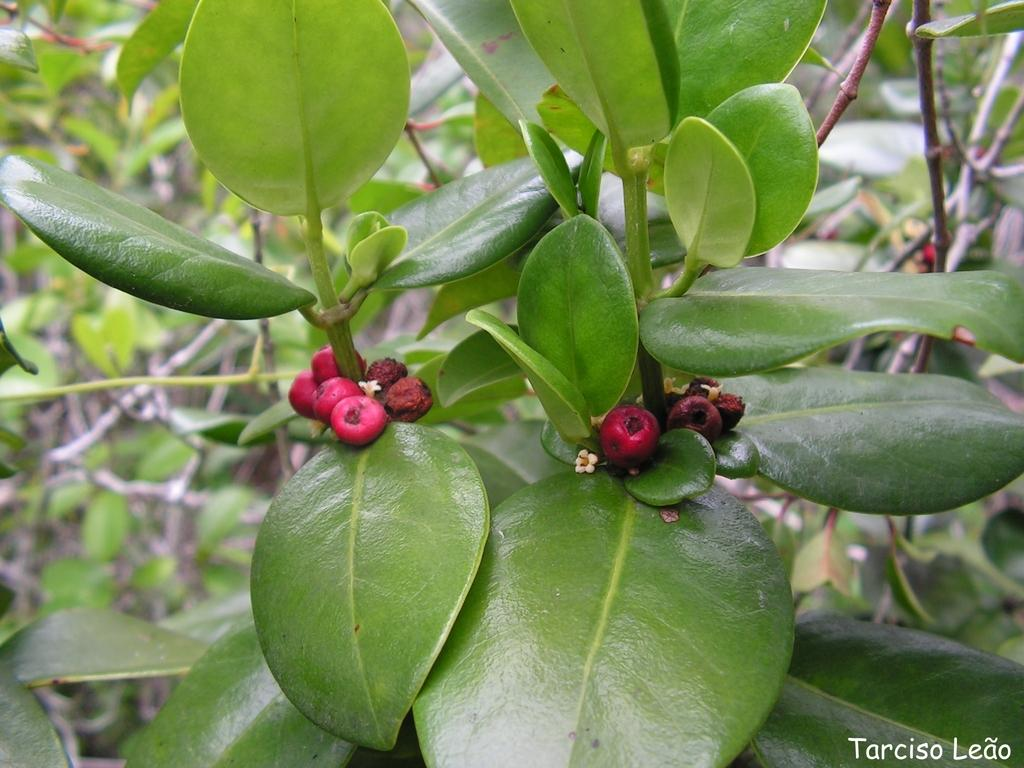What type of vegetation is present in the image? There are trees with fruits in the image. Can you describe any text visible in the image? There is text at the bottom right corner of the image. What type of party is being held in the image? There is no party present in the image; it features trees with fruits and text at the bottom right corner. How does the wind affect the trees in the image? The image does not depict any wind or its effects on the trees; it only shows the trees with fruits and text at the bottom right corner. 